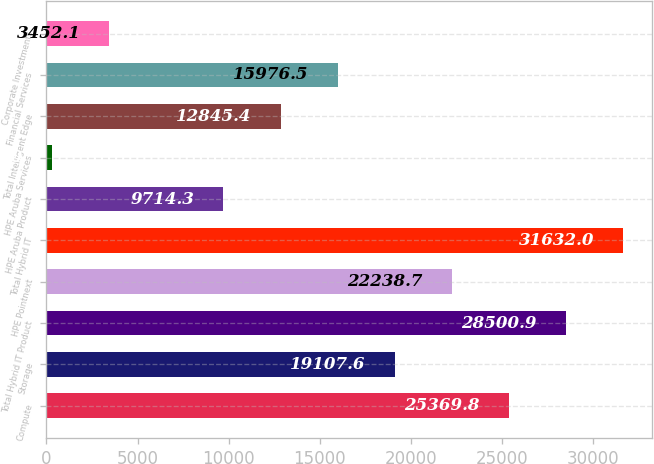<chart> <loc_0><loc_0><loc_500><loc_500><bar_chart><fcel>Compute<fcel>Storage<fcel>Total Hybrid IT Product<fcel>HPE Pointnext<fcel>Total Hybrid IT<fcel>HPE Aruba Product<fcel>HPE Aruba Services<fcel>Total Intelligent Edge<fcel>Financial Services<fcel>Corporate Investments<nl><fcel>25369.8<fcel>19107.6<fcel>28500.9<fcel>22238.7<fcel>31632<fcel>9714.3<fcel>321<fcel>12845.4<fcel>15976.5<fcel>3452.1<nl></chart> 